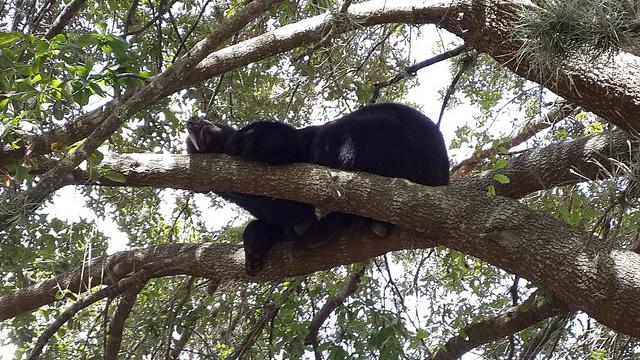Does the bear look safe?
Short answer required. Yes. What is the bear doing in the photo?
Be succinct. Sleeping. Is there a tree in the image?
Quick response, please. Yes. 